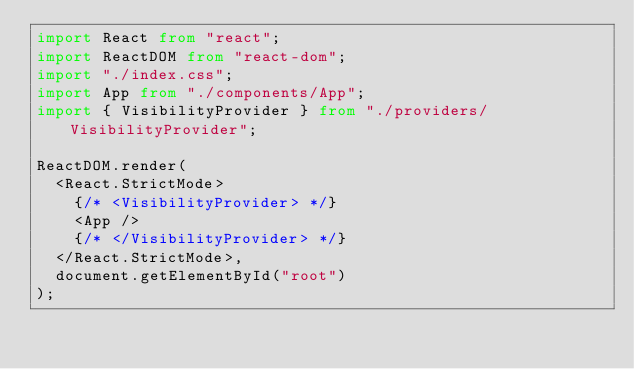<code> <loc_0><loc_0><loc_500><loc_500><_TypeScript_>import React from "react";
import ReactDOM from "react-dom";
import "./index.css";
import App from "./components/App";
import { VisibilityProvider } from "./providers/VisibilityProvider";

ReactDOM.render(
	<React.StrictMode>
		{/* <VisibilityProvider> */}
		<App />
		{/* </VisibilityProvider> */}
	</React.StrictMode>,
	document.getElementById("root")
);
</code> 